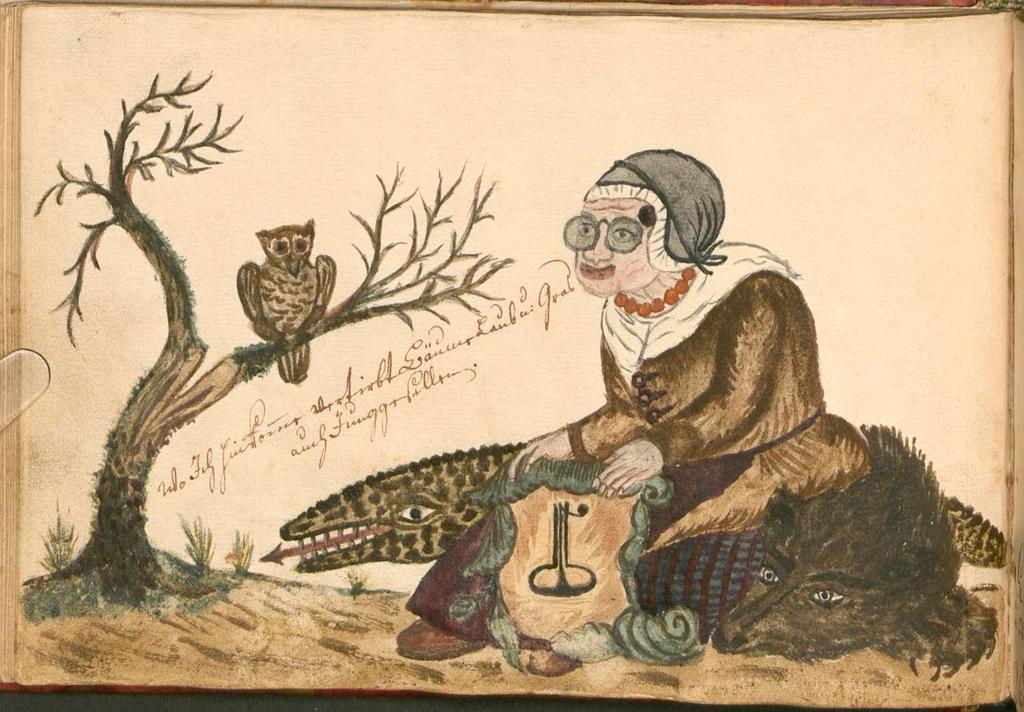Can you describe this image briefly? This is a painting,in this painting we can see a woman,crocodiles,owl and tree. 